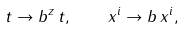Convert formula to latex. <formula><loc_0><loc_0><loc_500><loc_500>t \to b ^ { z } \, t , \quad x ^ { i } \to b \, x ^ { i } ,</formula> 